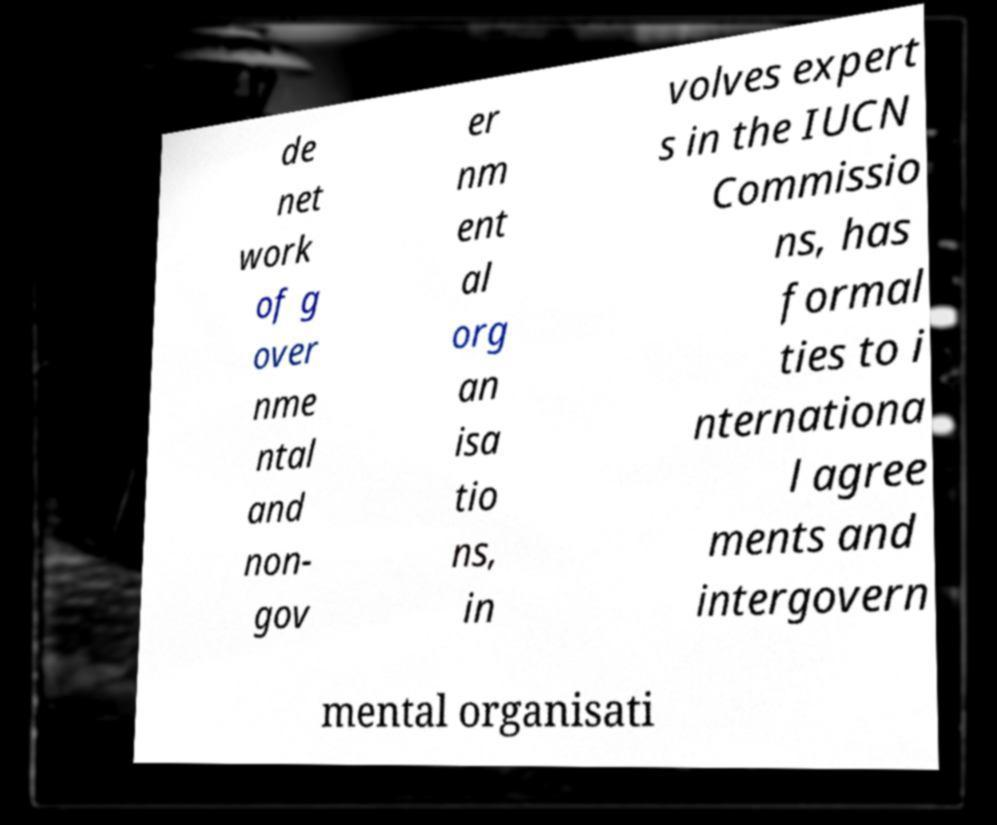I need the written content from this picture converted into text. Can you do that? de net work of g over nme ntal and non- gov er nm ent al org an isa tio ns, in volves expert s in the IUCN Commissio ns, has formal ties to i nternationa l agree ments and intergovern mental organisati 